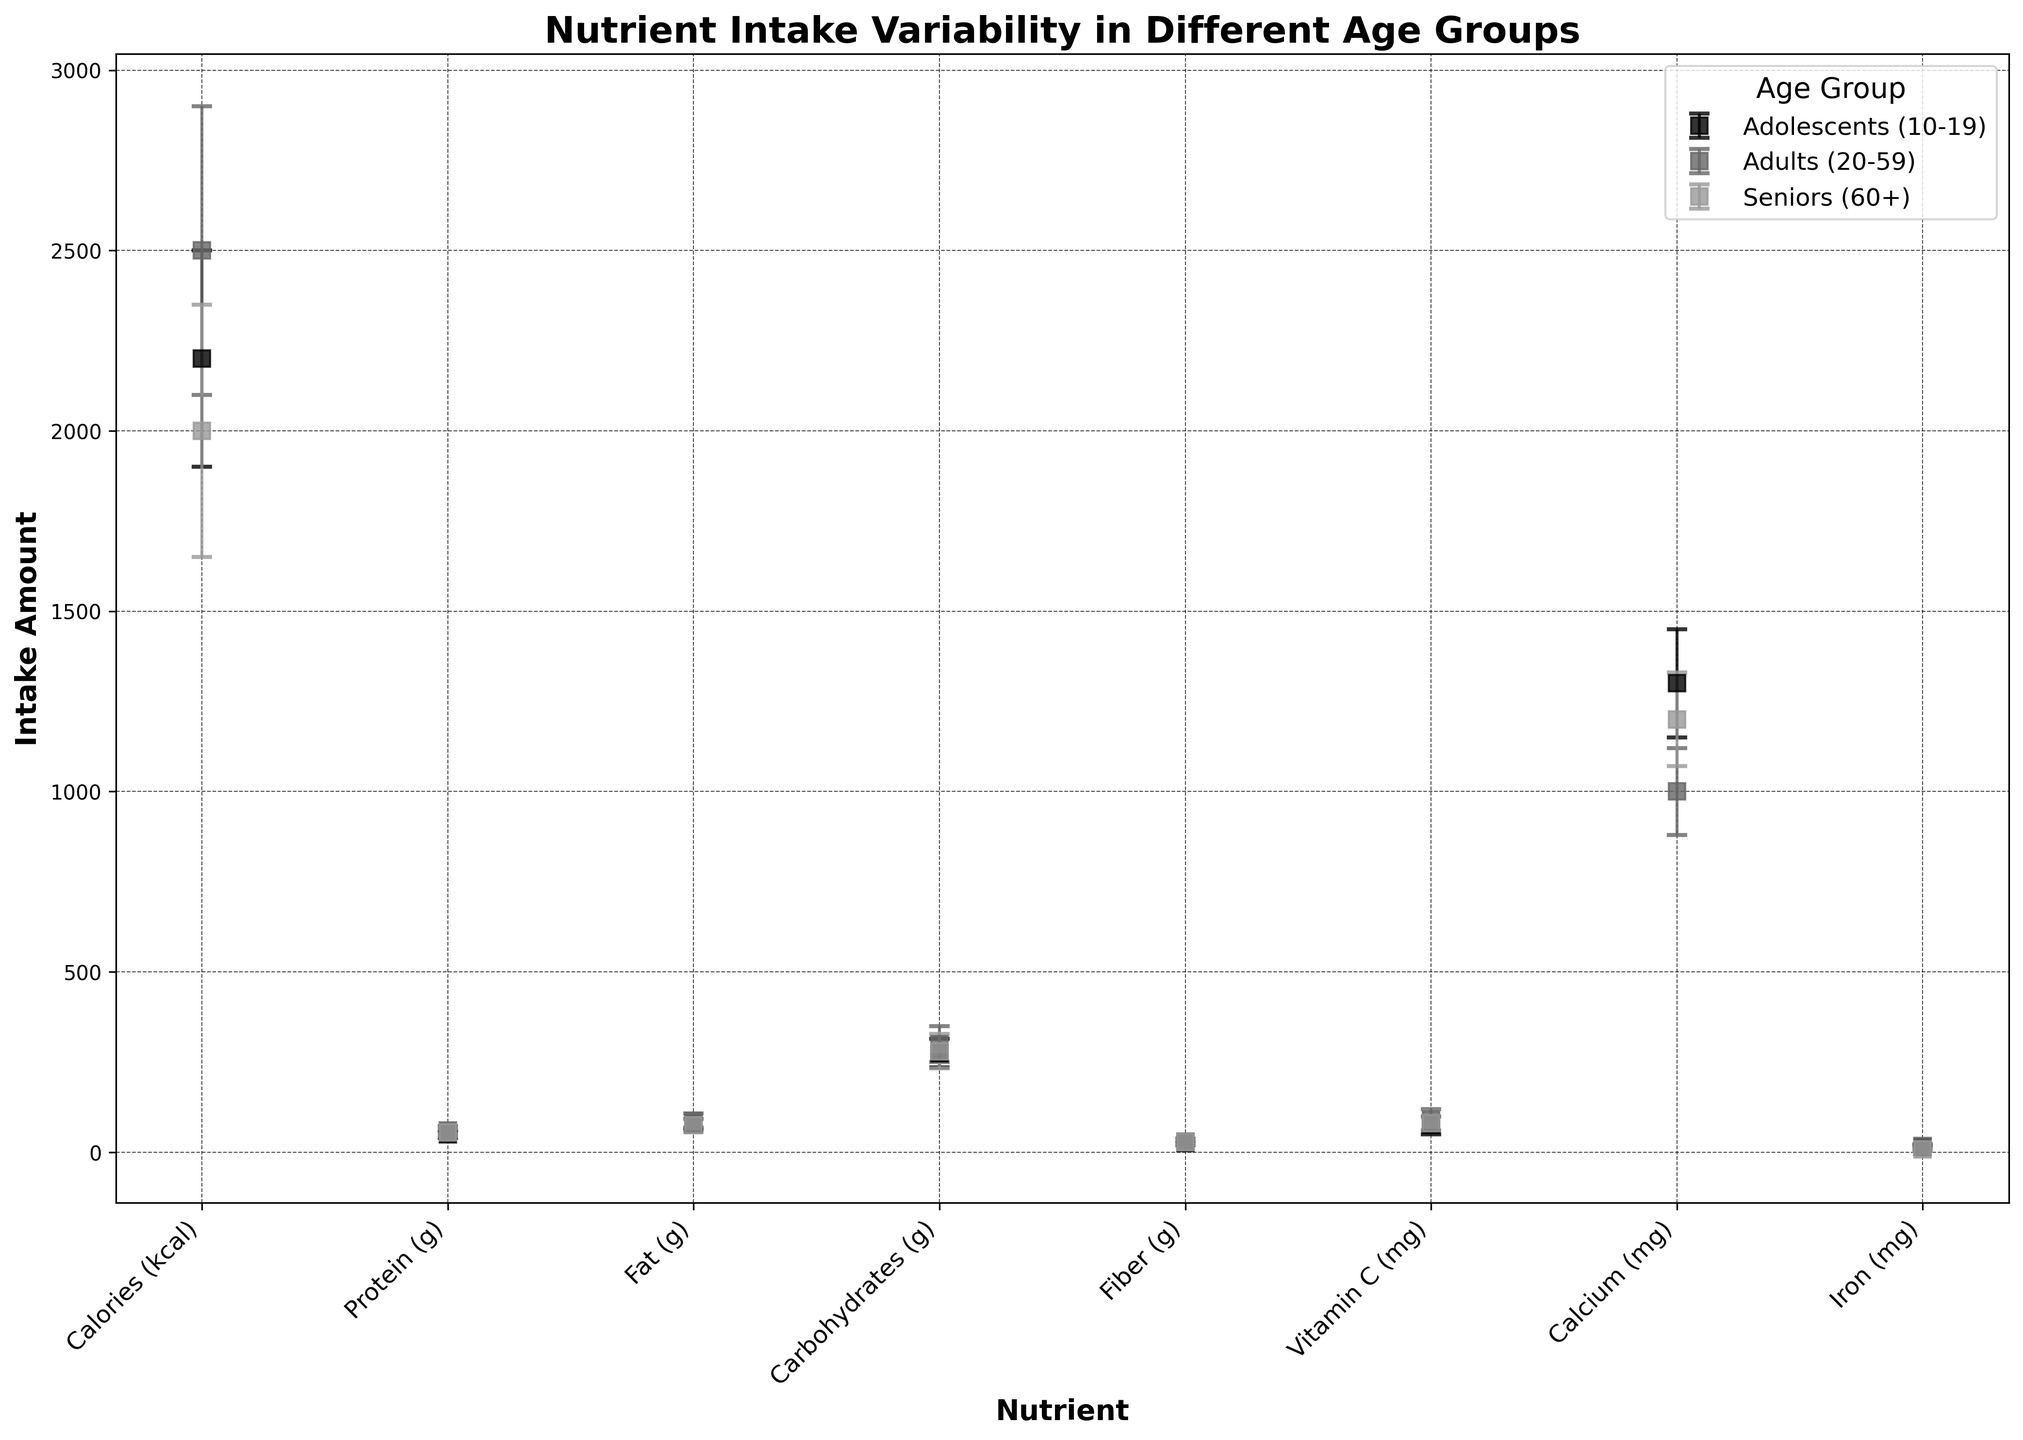Which age group has the highest mean intake of Calcium? By observing the figure, the mean intake values for Calcium can be compared across different age groups. According to the plot, "Adolescents (10-19)" has the highest mean intake for Calcium with an intake of 1300 mg.
Answer: Adolescents (10-19) Which nutrient shows the highest variability in intake for Adults (20-59)? The highest variability is indicated by the largest error bar in the plot. For Adults (20-59), the nutrient "Calories" has the largest standard deviation error bar of 400 kcal, making it the highest variability.
Answer: Calories Compare the average intake of Iron between Adolescents (10-19) and Seniors (60+). Which group has a higher intake and by how much? Observing the mean intake values for Iron: Adolescents have an intake of 15 mg, while Seniors have 8 mg. The difference is calculated as 15 - 8 = 7 mg, with Adolescents having the higher intake.
Answer: Adolescents by 7 mg For which nutrient do Seniors (60+) have the smallest standard deviation? The smallest standard deviation for Seniors (60+) is indicated by the smallest error bar. The smallest error bar among their nutrients is for Iron, with a standard deviation of 3 mg.
Answer: Iron By how much does the mean intake of Calories differ between Adults (20-59) and Seniors (60+)? Comparing the mean intake values for Calories: Adults have 2500 kcal, while Seniors have 2000 kcal. The difference is calculated as 2500 - 2000 = 500 kcal.
Answer: 500 kcal Which age group has the least mean intake of Fiber, and what is the difference between the highest and lowest intake levels? By looking at the mean intake values for Fiber across all age groups, Adolescents (10-19) have the least mean intake of 25 g. The highest intake comes from Adults (20-59) with 30 g. The difference is 30 - 25 = 5 g.
Answer: Adolescents (10-19) by 5 g Compare the standard deviations of Vitamin C intake between all age groups. Which group shows the highest variability, and what's the difference in variability between the highest and lowest groups? By examining the error bars for Vitamin C intake: Adolescents have 25 mg, Adults have 30 mg, and Seniors have 20 mg. Adults have the highest variability. The difference between Adults (highest, 30 mg) and Seniors (lowest, 20 mg) is 30 - 20 = 10 mg.
Answer: Adults by 10 mg For which age group is the mean intake of Carbohydrates closest to the overall average intake across all groups? The mean intake values for Carbohydrates are 275 g (Adolescents), 300 g (Adults), and 280 g (Seniors). Calculate the average across all groups: (275 + 300 + 280) / 3 ≈ 285 g. The intake closest to 285 g is 280 g for Seniors.
Answer: Seniors (60+) What is the sum of the mean Protein intake for all age groups? Summing the mean intake values for Protein: Adolescents have 50 g, Adults have 60 g, and Seniors have 55 g. The sum is 50 + 60 + 55 = 165 g.
Answer: 165 g 